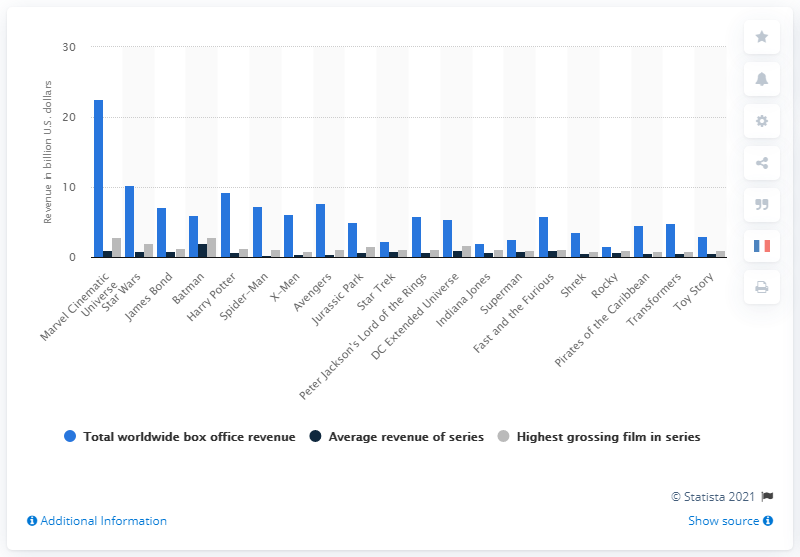Specify some key components in this picture. The average revenue per film in the Marvel Cinematic Universe was approximately 0.98. As of November 2020, the total worldwide box office revenue of the Marvel Cinematic Universe was approximately 22.56 billion USD. According to the worldwide box office revenue of Avengers: Endgame, the film generated approximately 2.8 billion US dollars. J.K. Rowling and James Bond lost to Star Wars in terms of revenue. 